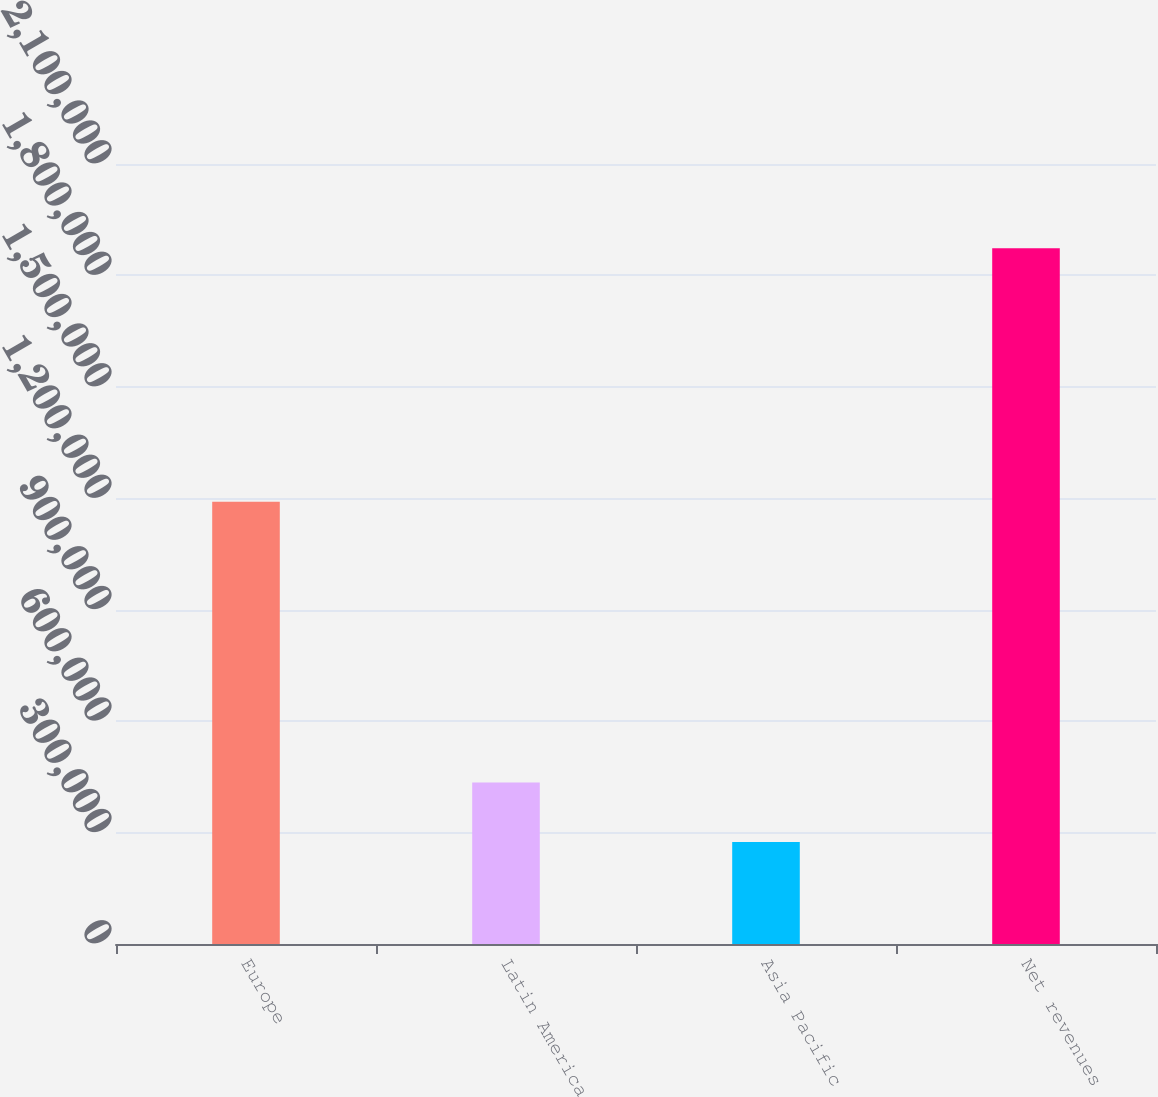Convert chart. <chart><loc_0><loc_0><loc_500><loc_500><bar_chart><fcel>Europe<fcel>Latin America<fcel>Asia Pacific<fcel>Net revenues<nl><fcel>1.19035e+06<fcel>434726<fcel>274920<fcel>1.87298e+06<nl></chart> 